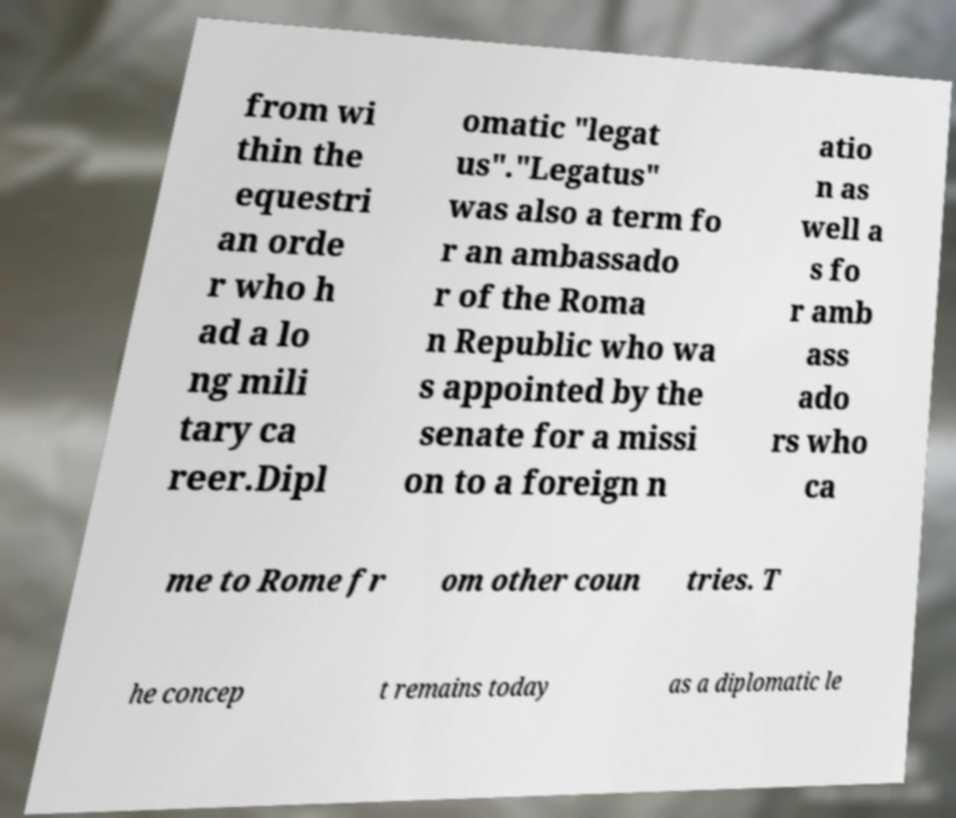Could you extract and type out the text from this image? from wi thin the equestri an orde r who h ad a lo ng mili tary ca reer.Dipl omatic "legat us"."Legatus" was also a term fo r an ambassado r of the Roma n Republic who wa s appointed by the senate for a missi on to a foreign n atio n as well a s fo r amb ass ado rs who ca me to Rome fr om other coun tries. T he concep t remains today as a diplomatic le 